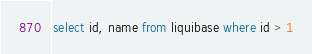<code> <loc_0><loc_0><loc_500><loc_500><_SQL_>select id, name from liquibase where id > 1</code> 